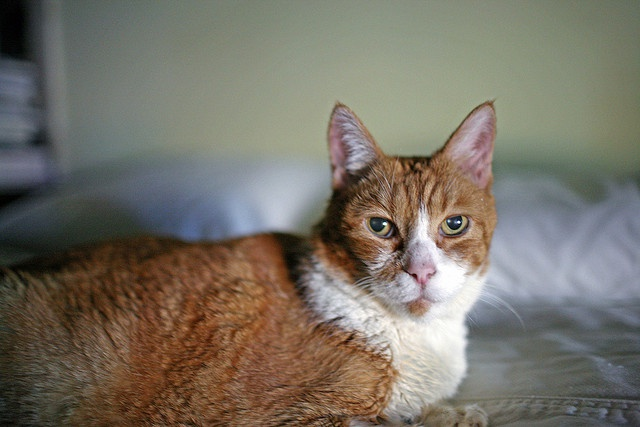Describe the objects in this image and their specific colors. I can see cat in black, maroon, and gray tones and bed in black, gray, and darkgray tones in this image. 